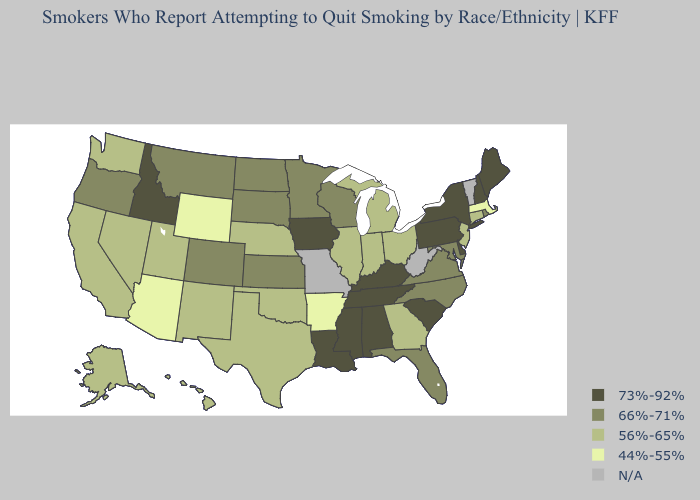What is the lowest value in states that border Kentucky?
Write a very short answer. 56%-65%. Name the states that have a value in the range 44%-55%?
Short answer required. Arizona, Arkansas, Massachusetts, Wyoming. What is the highest value in states that border Oklahoma?
Write a very short answer. 66%-71%. What is the lowest value in the USA?
Short answer required. 44%-55%. Name the states that have a value in the range 56%-65%?
Quick response, please. Alaska, California, Connecticut, Georgia, Hawaii, Illinois, Indiana, Michigan, Nebraska, Nevada, New Jersey, New Mexico, Ohio, Oklahoma, Texas, Utah, Washington. Name the states that have a value in the range 66%-71%?
Quick response, please. Colorado, Florida, Kansas, Maryland, Minnesota, Montana, North Carolina, North Dakota, Oregon, Rhode Island, South Dakota, Virginia, Wisconsin. Name the states that have a value in the range N/A?
Be succinct. Missouri, Vermont, West Virginia. Does Virginia have the lowest value in the South?
Keep it brief. No. What is the value of Kansas?
Quick response, please. 66%-71%. What is the value of Maine?
Concise answer only. 73%-92%. What is the value of Mississippi?
Be succinct. 73%-92%. What is the lowest value in the MidWest?
Give a very brief answer. 56%-65%. What is the value of Rhode Island?
Write a very short answer. 66%-71%. Name the states that have a value in the range 56%-65%?
Give a very brief answer. Alaska, California, Connecticut, Georgia, Hawaii, Illinois, Indiana, Michigan, Nebraska, Nevada, New Jersey, New Mexico, Ohio, Oklahoma, Texas, Utah, Washington. What is the value of Nevada?
Quick response, please. 56%-65%. 